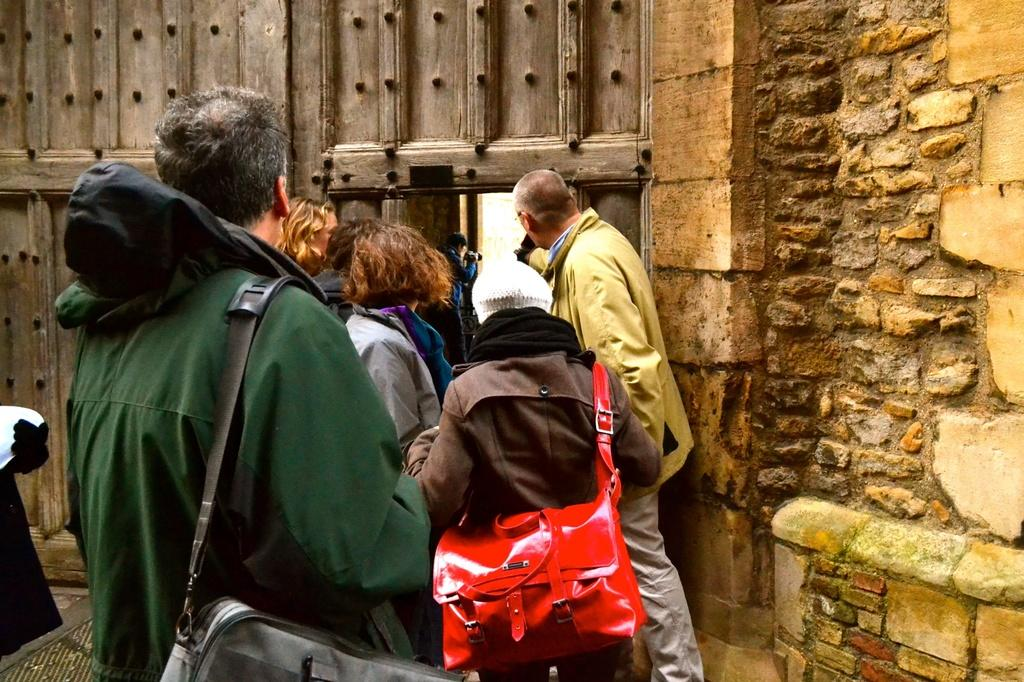Who is present in the image? There are people in the image, including men and women. Can you describe the setting of the image? There is a stone wall on the right side of the image and a door in the background. What type of bedroom can be seen in the image? There is no bedroom present in the image; it features people and a stone wall with a door in the background. How many people are learning in the image? There is no indication of learning or education in the image; it simply shows people, a stone wall, and a door. 